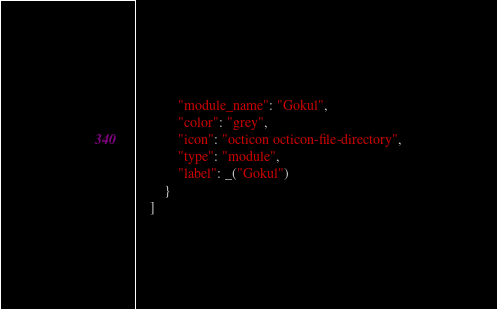<code> <loc_0><loc_0><loc_500><loc_500><_Python_>			"module_name": "Gokul",
			"color": "grey",
			"icon": "octicon octicon-file-directory",
			"type": "module",
			"label": _("Gokul")
		}
	]
</code> 